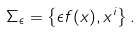<formula> <loc_0><loc_0><loc_500><loc_500>\Sigma _ { \epsilon } = \left \{ \epsilon f ( x ) , x ^ { i } \right \} .</formula> 